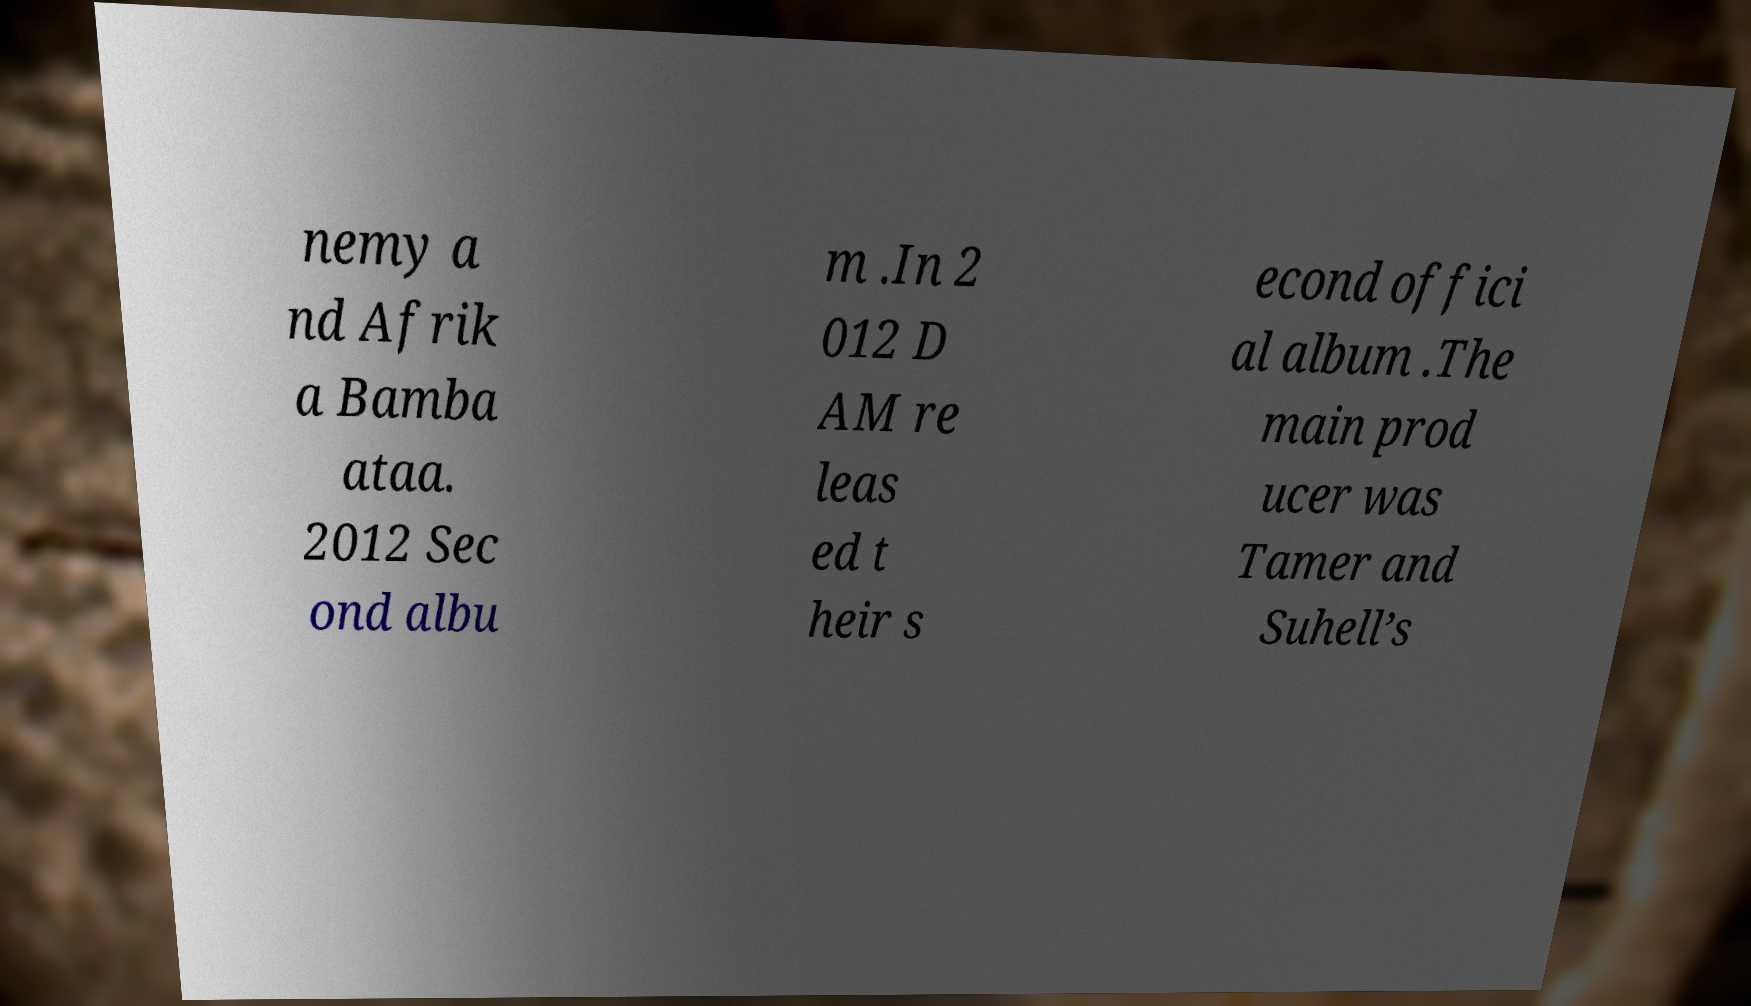What messages or text are displayed in this image? I need them in a readable, typed format. nemy a nd Afrik a Bamba ataa. 2012 Sec ond albu m .In 2 012 D AM re leas ed t heir s econd offici al album .The main prod ucer was Tamer and Suhell’s 